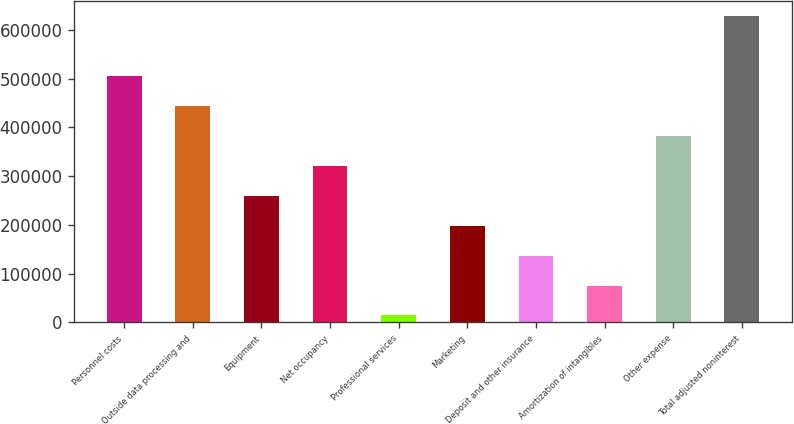Convert chart to OTSL. <chart><loc_0><loc_0><loc_500><loc_500><bar_chart><fcel>Personnel costs<fcel>Outside data processing and<fcel>Equipment<fcel>Net occupancy<fcel>Professional services<fcel>Marketing<fcel>Deposit and other insurance<fcel>Amortization of intangibles<fcel>Other expense<fcel>Total adjusted noninterest<nl><fcel>505279<fcel>443872<fcel>259652<fcel>321058<fcel>14024<fcel>198245<fcel>136838<fcel>75430.9<fcel>382465<fcel>628093<nl></chart> 